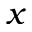Convert formula to latex. <formula><loc_0><loc_0><loc_500><loc_500>x</formula> 